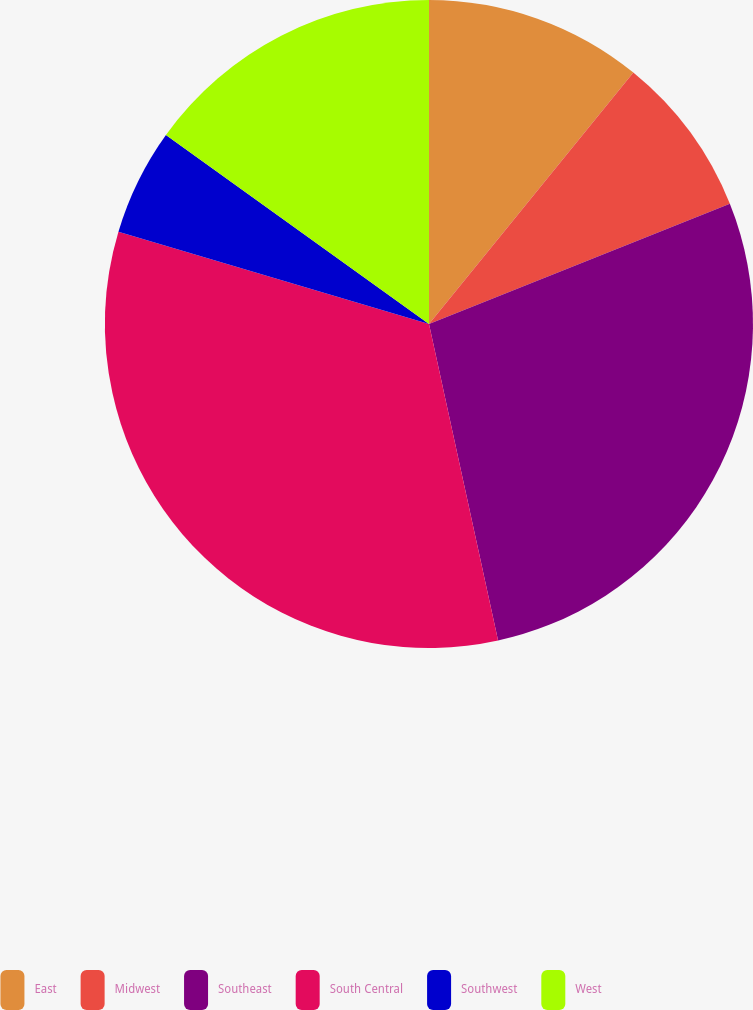Convert chart. <chart><loc_0><loc_0><loc_500><loc_500><pie_chart><fcel>East<fcel>Midwest<fcel>Southeast<fcel>South Central<fcel>Southwest<fcel>West<nl><fcel>10.86%<fcel>8.09%<fcel>27.63%<fcel>33.02%<fcel>5.32%<fcel>15.08%<nl></chart> 